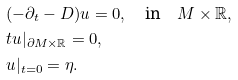Convert formula to latex. <formula><loc_0><loc_0><loc_500><loc_500>& ( - \partial _ { t } - D ) u = 0 , \quad \text {in} \quad M \times \mathbb { R } , \\ & t u | _ { \partial M \times \mathbb { R } } = 0 , \\ & u | _ { t = 0 } = \eta .</formula> 